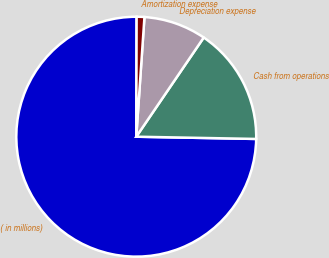<chart> <loc_0><loc_0><loc_500><loc_500><pie_chart><fcel>( in millions)<fcel>Cash from operations<fcel>Depreciation expense<fcel>Amortization expense<nl><fcel>74.75%<fcel>15.79%<fcel>8.42%<fcel>1.04%<nl></chart> 